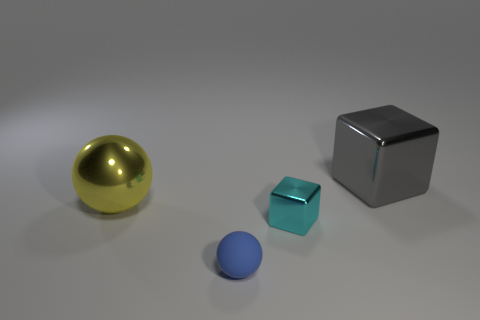What color is the ball that is in front of the big metal object left of the object that is on the right side of the small cyan shiny block?
Offer a very short reply. Blue. Is there any other thing that is the same size as the gray shiny block?
Give a very brief answer. Yes. There is a big block; is its color the same as the metallic thing that is in front of the large metallic ball?
Make the answer very short. No. What color is the big cube?
Keep it short and to the point. Gray. The big thing to the left of the cube that is behind the large object that is in front of the gray cube is what shape?
Provide a short and direct response. Sphere. Is the number of tiny blue spheres that are behind the yellow object greater than the number of small cubes behind the cyan metal object?
Your answer should be very brief. No. Are there any gray metallic objects to the left of the large yellow sphere?
Offer a very short reply. No. There is a thing that is both on the right side of the tiny ball and behind the cyan block; what is its material?
Your response must be concise. Metal. There is a large metal thing that is the same shape as the blue matte object; what color is it?
Your answer should be compact. Yellow. Are there any blue rubber spheres behind the shiny block that is in front of the gray block?
Offer a very short reply. No. 